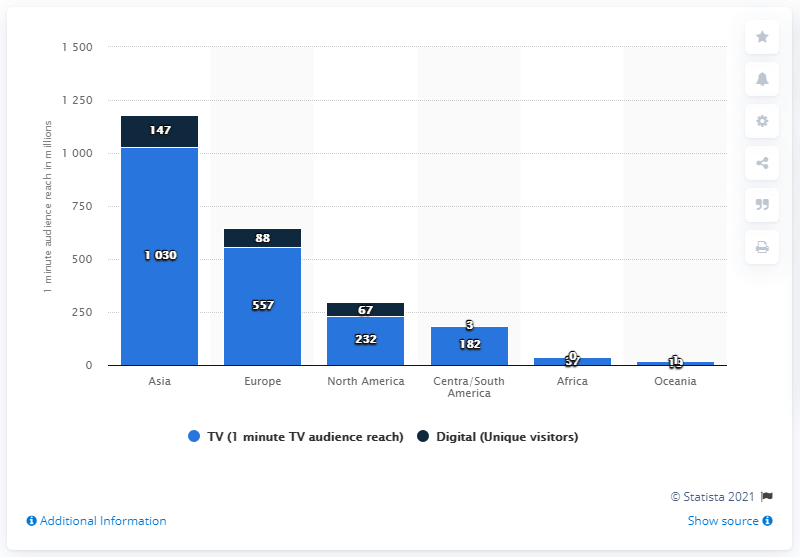Mention a couple of crucial points in this snapshot. The Sochi Winter Olympics were watched by 37 people in Africa. 